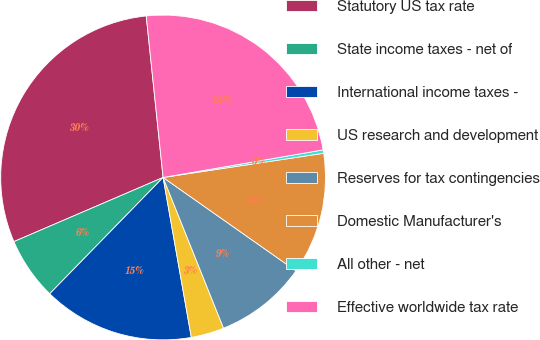<chart> <loc_0><loc_0><loc_500><loc_500><pie_chart><fcel>Statutory US tax rate<fcel>State income taxes - net of<fcel>International income taxes -<fcel>US research and development<fcel>Reserves for tax contingencies<fcel>Domestic Manufacturer's<fcel>All other - net<fcel>Effective worldwide tax rate<nl><fcel>29.81%<fcel>6.24%<fcel>15.08%<fcel>3.29%<fcel>9.18%<fcel>12.13%<fcel>0.34%<fcel>23.94%<nl></chart> 